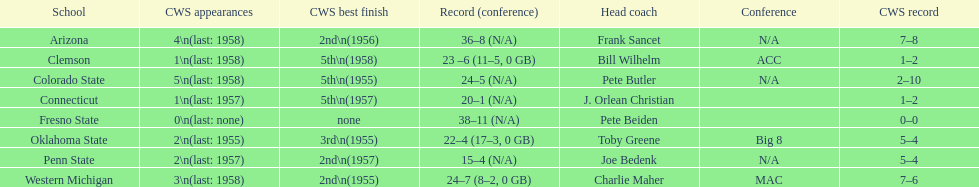List the schools that came in last place in the cws best finish. Clemson, Colorado State, Connecticut. 